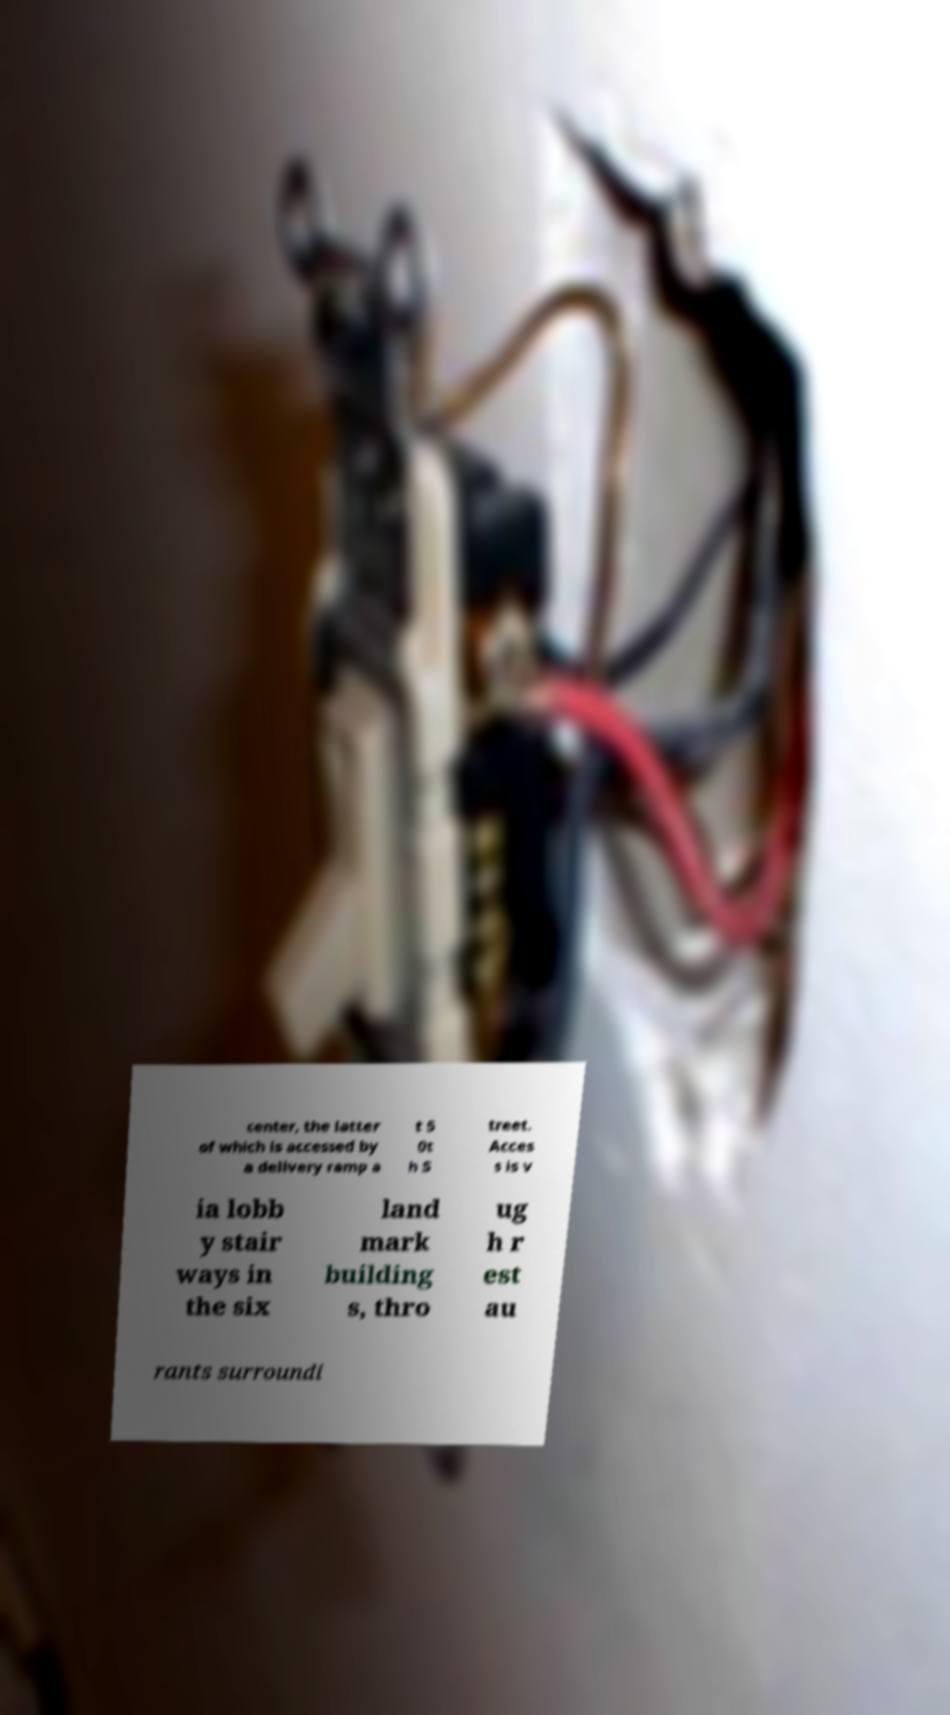Could you assist in decoding the text presented in this image and type it out clearly? center, the latter of which is accessed by a delivery ramp a t 5 0t h S treet. Acces s is v ia lobb y stair ways in the six land mark building s, thro ug h r est au rants surroundi 